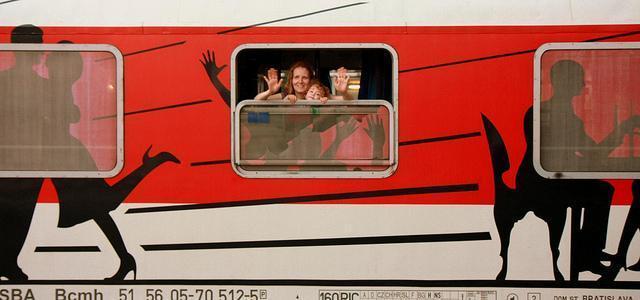How many people?
Give a very brief answer. 2. How many cows are there?
Give a very brief answer. 0. 